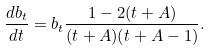<formula> <loc_0><loc_0><loc_500><loc_500>\frac { d b _ { t } } { d t } = b _ { t } \frac { 1 - 2 ( t + A ) } { ( t + A ) ( t + A - 1 ) } .</formula> 